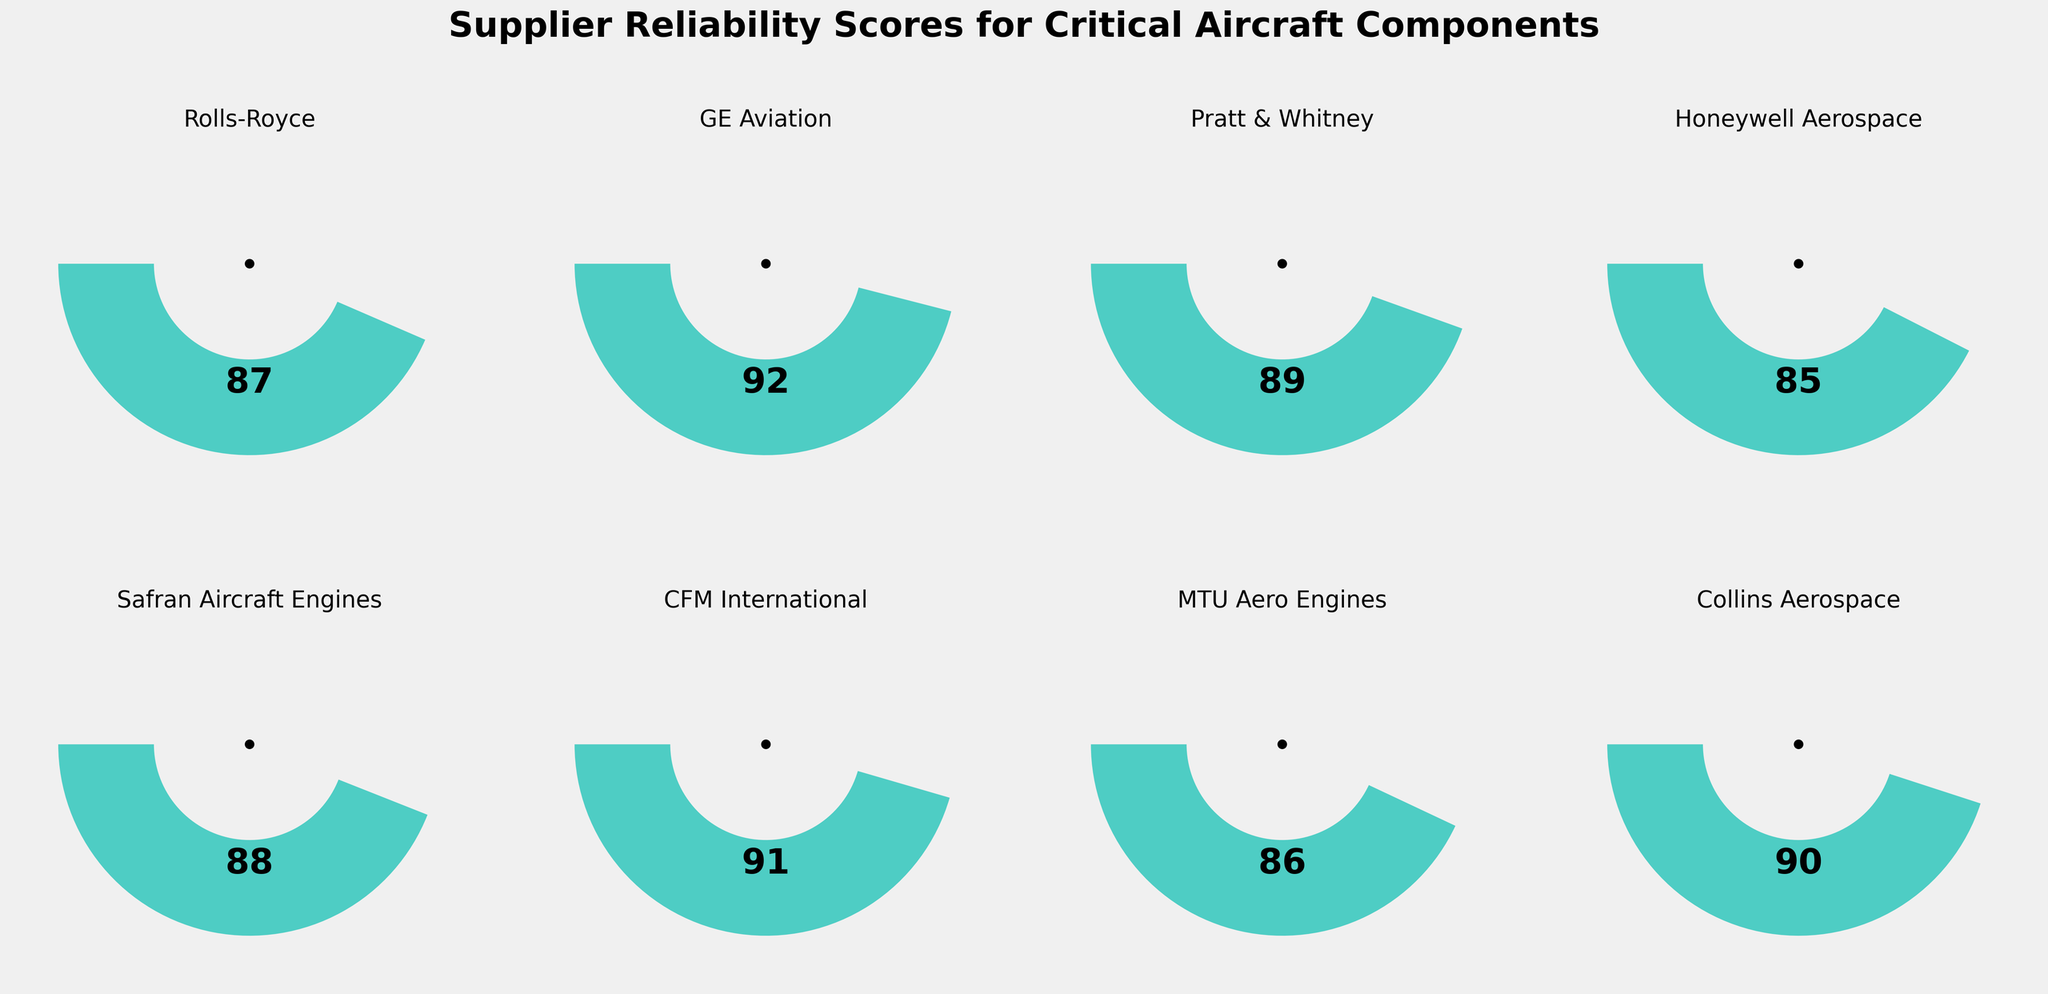What's the highest reliability score among the suppliers? The highest reliability score can be found by checking the gauge charts for each supplier. The highest value shown in the gauges is 92 for GE Aviation.
Answer: 92 Which supplier has the lowest reliability score? To determine the supplier with the lowest reliability score, compare all the scores in the gauge charts. The lowest score is 85 for Honeywell Aerospace.
Answer: Honeywell Aerospace What's the average reliability score of all the suppliers? Calculate the average by summing all the reliability scores and dividing by the number of suppliers. The scores are 87, 92, 89, 85, 88, 91, 86, and 90. The sum is 708 and there are 8 suppliers, so the average score is 708/8 = 88.5
Answer: 88.5 Which suppliers have a reliability score higher than 90? Identify suppliers whose gauge charts show a score greater than 90. The suppliers with scores above 90 are GE Aviation (92) and CFM International (91).
Answer: GE Aviation, CFM International What’s the difference between the highest and lowest reliability scores? Calculate the difference between the highest and lowest scores. The highest score is 92 (GE Aviation), and the lowest is 85 (Honeywell Aerospace). The difference is 92 - 85 = 7.
Answer: 7 How many suppliers have a reliability score between 85 and 90 inclusively? Count the suppliers whose scores fall in the range from 85 to 90 inclusively by checking each gauge. Those suppliers are Rolls-Royce (87), Pratt & Whitney (89), Honeywell Aerospace (85), Safran Aircraft Engines (88), MTU Aero Engines (86), and Collins Aerospace (90). There are 6 suppliers in this range.
Answer: 6 Which suppliers have a reliability score exactly equal to 90? Check the gauge charts to find any supplier with a reliability score of exactly 90. Collins Aerospace has a score of 90.
Answer: Collins Aerospace What's the median reliability score among the suppliers? Arrange the scores in ascending order (85, 86, 87, 88, 89, 90, 91, 92). The median value is the average of the middle two scores (88 and 89), so the median is (88 + 89) / 2 = 88.5.
Answer: 88.5 What’s the total number of suppliers represented in the figure? Count the total number of gauge charts representing the suppliers. There are 8 gauge charts, each representing a different supplier.
Answer: 8 